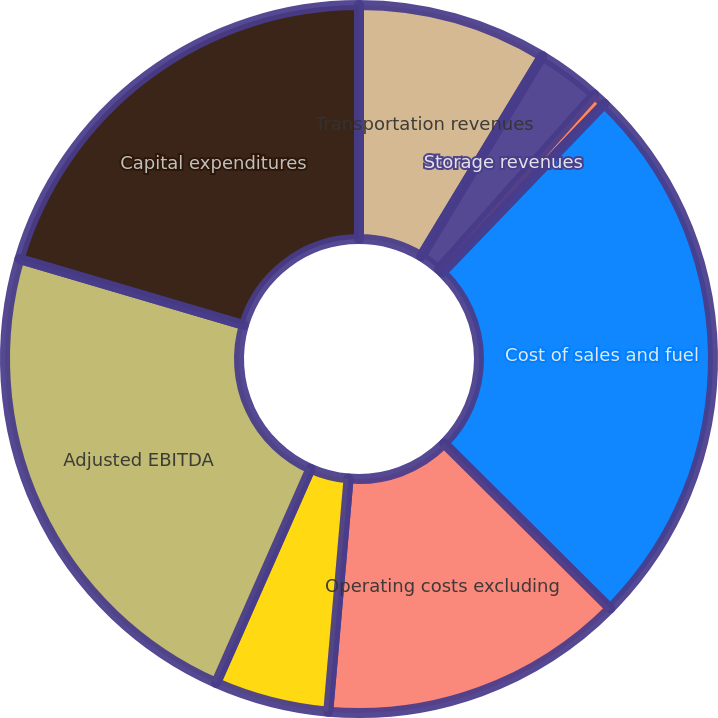Convert chart to OTSL. <chart><loc_0><loc_0><loc_500><loc_500><pie_chart><fcel>Transportation revenues<fcel>Storage revenues<fcel>Natural gas sales and other<fcel>Cost of sales and fuel<fcel>Operating costs excluding<fcel>Equity in net earnings from<fcel>Adjusted EBITDA<fcel>Capital expenditures<nl><fcel>8.66%<fcel>2.92%<fcel>0.61%<fcel>25.26%<fcel>13.94%<fcel>5.23%<fcel>22.95%<fcel>20.44%<nl></chart> 